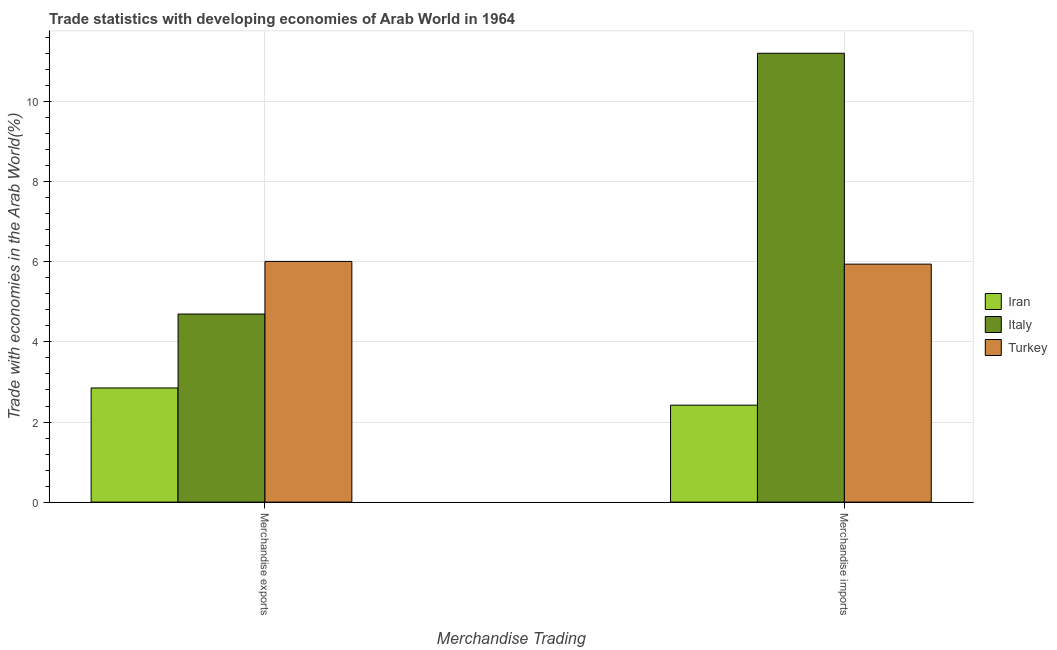Are the number of bars per tick equal to the number of legend labels?
Your answer should be very brief. Yes. What is the label of the 2nd group of bars from the left?
Provide a short and direct response. Merchandise imports. What is the merchandise imports in Italy?
Provide a short and direct response. 11.21. Across all countries, what is the maximum merchandise exports?
Offer a very short reply. 6.01. Across all countries, what is the minimum merchandise exports?
Provide a succinct answer. 2.85. In which country was the merchandise imports maximum?
Keep it short and to the point. Italy. In which country was the merchandise imports minimum?
Your answer should be compact. Iran. What is the total merchandise exports in the graph?
Your answer should be very brief. 13.56. What is the difference between the merchandise imports in Italy and that in Iran?
Provide a short and direct response. 8.79. What is the difference between the merchandise exports in Iran and the merchandise imports in Italy?
Keep it short and to the point. -8.36. What is the average merchandise exports per country?
Provide a succinct answer. 4.52. What is the difference between the merchandise imports and merchandise exports in Italy?
Your answer should be compact. 6.51. In how many countries, is the merchandise imports greater than 9.6 %?
Your answer should be very brief. 1. What is the ratio of the merchandise exports in Turkey to that in Italy?
Your answer should be very brief. 1.28. What does the 1st bar from the left in Merchandise imports represents?
Your response must be concise. Iran. What does the 2nd bar from the right in Merchandise imports represents?
Offer a terse response. Italy. Are the values on the major ticks of Y-axis written in scientific E-notation?
Keep it short and to the point. No. Does the graph contain any zero values?
Your response must be concise. No. Does the graph contain grids?
Offer a very short reply. Yes. What is the title of the graph?
Your response must be concise. Trade statistics with developing economies of Arab World in 1964. What is the label or title of the X-axis?
Offer a very short reply. Merchandise Trading. What is the label or title of the Y-axis?
Your answer should be very brief. Trade with economies in the Arab World(%). What is the Trade with economies in the Arab World(%) of Iran in Merchandise exports?
Your answer should be very brief. 2.85. What is the Trade with economies in the Arab World(%) in Italy in Merchandise exports?
Offer a very short reply. 4.7. What is the Trade with economies in the Arab World(%) of Turkey in Merchandise exports?
Your answer should be compact. 6.01. What is the Trade with economies in the Arab World(%) of Iran in Merchandise imports?
Make the answer very short. 2.42. What is the Trade with economies in the Arab World(%) of Italy in Merchandise imports?
Your answer should be very brief. 11.21. What is the Trade with economies in the Arab World(%) of Turkey in Merchandise imports?
Ensure brevity in your answer.  5.94. Across all Merchandise Trading, what is the maximum Trade with economies in the Arab World(%) of Iran?
Offer a very short reply. 2.85. Across all Merchandise Trading, what is the maximum Trade with economies in the Arab World(%) in Italy?
Ensure brevity in your answer.  11.21. Across all Merchandise Trading, what is the maximum Trade with economies in the Arab World(%) in Turkey?
Your response must be concise. 6.01. Across all Merchandise Trading, what is the minimum Trade with economies in the Arab World(%) of Iran?
Provide a succinct answer. 2.42. Across all Merchandise Trading, what is the minimum Trade with economies in the Arab World(%) in Italy?
Offer a very short reply. 4.7. Across all Merchandise Trading, what is the minimum Trade with economies in the Arab World(%) of Turkey?
Your answer should be very brief. 5.94. What is the total Trade with economies in the Arab World(%) in Iran in the graph?
Provide a short and direct response. 5.27. What is the total Trade with economies in the Arab World(%) of Italy in the graph?
Offer a very short reply. 15.91. What is the total Trade with economies in the Arab World(%) of Turkey in the graph?
Provide a short and direct response. 11.95. What is the difference between the Trade with economies in the Arab World(%) in Iran in Merchandise exports and that in Merchandise imports?
Make the answer very short. 0.43. What is the difference between the Trade with economies in the Arab World(%) of Italy in Merchandise exports and that in Merchandise imports?
Your answer should be very brief. -6.51. What is the difference between the Trade with economies in the Arab World(%) of Turkey in Merchandise exports and that in Merchandise imports?
Keep it short and to the point. 0.07. What is the difference between the Trade with economies in the Arab World(%) of Iran in Merchandise exports and the Trade with economies in the Arab World(%) of Italy in Merchandise imports?
Your response must be concise. -8.36. What is the difference between the Trade with economies in the Arab World(%) of Iran in Merchandise exports and the Trade with economies in the Arab World(%) of Turkey in Merchandise imports?
Your answer should be very brief. -3.09. What is the difference between the Trade with economies in the Arab World(%) in Italy in Merchandise exports and the Trade with economies in the Arab World(%) in Turkey in Merchandise imports?
Offer a terse response. -1.25. What is the average Trade with economies in the Arab World(%) of Iran per Merchandise Trading?
Offer a very short reply. 2.64. What is the average Trade with economies in the Arab World(%) in Italy per Merchandise Trading?
Ensure brevity in your answer.  7.95. What is the average Trade with economies in the Arab World(%) of Turkey per Merchandise Trading?
Make the answer very short. 5.98. What is the difference between the Trade with economies in the Arab World(%) of Iran and Trade with economies in the Arab World(%) of Italy in Merchandise exports?
Give a very brief answer. -1.85. What is the difference between the Trade with economies in the Arab World(%) in Iran and Trade with economies in the Arab World(%) in Turkey in Merchandise exports?
Provide a short and direct response. -3.16. What is the difference between the Trade with economies in the Arab World(%) of Italy and Trade with economies in the Arab World(%) of Turkey in Merchandise exports?
Ensure brevity in your answer.  -1.31. What is the difference between the Trade with economies in the Arab World(%) in Iran and Trade with economies in the Arab World(%) in Italy in Merchandise imports?
Provide a succinct answer. -8.79. What is the difference between the Trade with economies in the Arab World(%) in Iran and Trade with economies in the Arab World(%) in Turkey in Merchandise imports?
Your answer should be compact. -3.52. What is the difference between the Trade with economies in the Arab World(%) of Italy and Trade with economies in the Arab World(%) of Turkey in Merchandise imports?
Provide a short and direct response. 5.27. What is the ratio of the Trade with economies in the Arab World(%) of Iran in Merchandise exports to that in Merchandise imports?
Ensure brevity in your answer.  1.18. What is the ratio of the Trade with economies in the Arab World(%) of Italy in Merchandise exports to that in Merchandise imports?
Your answer should be very brief. 0.42. What is the ratio of the Trade with economies in the Arab World(%) in Turkey in Merchandise exports to that in Merchandise imports?
Make the answer very short. 1.01. What is the difference between the highest and the second highest Trade with economies in the Arab World(%) in Iran?
Keep it short and to the point. 0.43. What is the difference between the highest and the second highest Trade with economies in the Arab World(%) of Italy?
Offer a very short reply. 6.51. What is the difference between the highest and the second highest Trade with economies in the Arab World(%) in Turkey?
Give a very brief answer. 0.07. What is the difference between the highest and the lowest Trade with economies in the Arab World(%) of Iran?
Offer a very short reply. 0.43. What is the difference between the highest and the lowest Trade with economies in the Arab World(%) of Italy?
Ensure brevity in your answer.  6.51. What is the difference between the highest and the lowest Trade with economies in the Arab World(%) of Turkey?
Your answer should be compact. 0.07. 